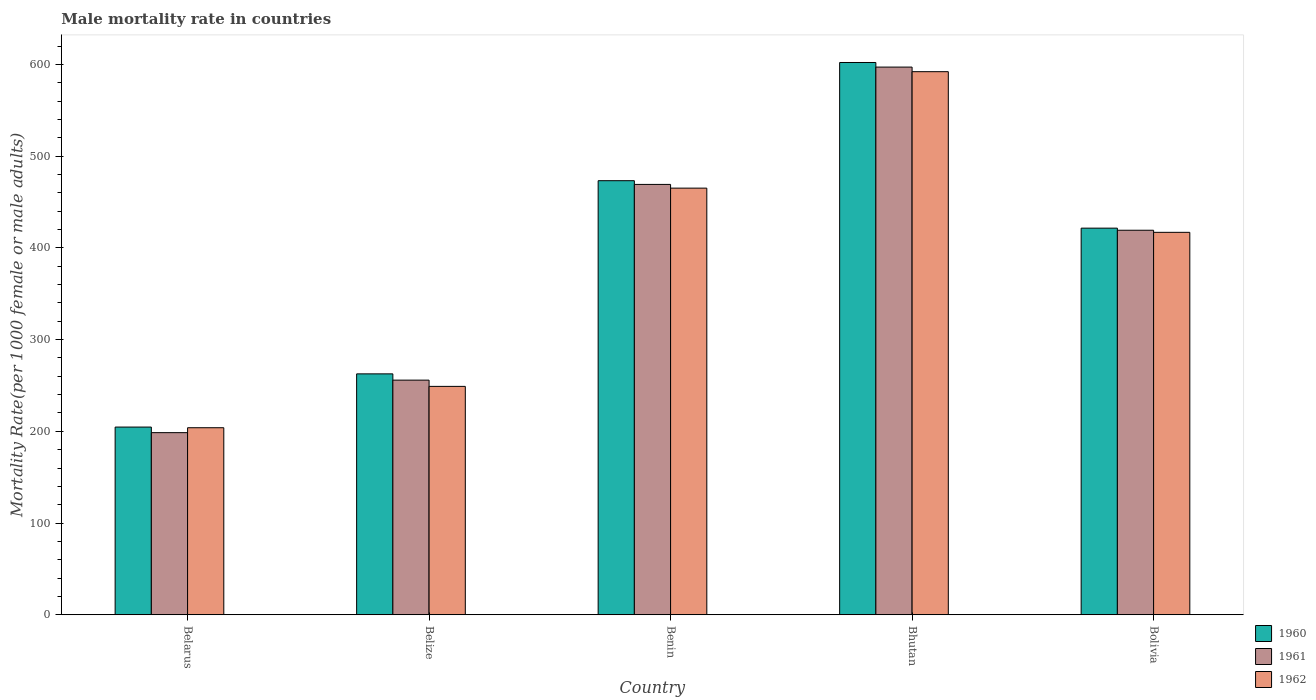Are the number of bars per tick equal to the number of legend labels?
Your response must be concise. Yes. What is the label of the 5th group of bars from the left?
Your answer should be very brief. Bolivia. What is the male mortality rate in 1962 in Bolivia?
Provide a succinct answer. 416.93. Across all countries, what is the maximum male mortality rate in 1960?
Offer a very short reply. 602.1. Across all countries, what is the minimum male mortality rate in 1962?
Offer a terse response. 203.93. In which country was the male mortality rate in 1960 maximum?
Keep it short and to the point. Bhutan. In which country was the male mortality rate in 1961 minimum?
Offer a terse response. Belarus. What is the total male mortality rate in 1960 in the graph?
Your answer should be compact. 1964.12. What is the difference between the male mortality rate in 1961 in Belize and that in Bhutan?
Your answer should be very brief. -341.27. What is the difference between the male mortality rate in 1960 in Belize and the male mortality rate in 1961 in Benin?
Keep it short and to the point. -206.54. What is the average male mortality rate in 1960 per country?
Your answer should be very brief. 392.82. What is the difference between the male mortality rate of/in 1961 and male mortality rate of/in 1960 in Belarus?
Your response must be concise. -6.1. In how many countries, is the male mortality rate in 1960 greater than 180?
Your answer should be compact. 5. What is the ratio of the male mortality rate in 1961 in Bhutan to that in Bolivia?
Your answer should be very brief. 1.42. What is the difference between the highest and the second highest male mortality rate in 1960?
Offer a terse response. -128.86. What is the difference between the highest and the lowest male mortality rate in 1960?
Make the answer very short. 397.45. Is the sum of the male mortality rate in 1962 in Belarus and Bolivia greater than the maximum male mortality rate in 1960 across all countries?
Give a very brief answer. Yes. What does the 1st bar from the left in Belize represents?
Offer a terse response. 1960. What does the 2nd bar from the right in Bolivia represents?
Provide a short and direct response. 1961. Is it the case that in every country, the sum of the male mortality rate in 1962 and male mortality rate in 1960 is greater than the male mortality rate in 1961?
Provide a succinct answer. Yes. How many bars are there?
Your response must be concise. 15. Are all the bars in the graph horizontal?
Your answer should be compact. No. How many countries are there in the graph?
Make the answer very short. 5. How many legend labels are there?
Keep it short and to the point. 3. What is the title of the graph?
Your response must be concise. Male mortality rate in countries. What is the label or title of the X-axis?
Keep it short and to the point. Country. What is the label or title of the Y-axis?
Give a very brief answer. Mortality Rate(per 1000 female or male adults). What is the Mortality Rate(per 1000 female or male adults) of 1960 in Belarus?
Offer a terse response. 204.65. What is the Mortality Rate(per 1000 female or male adults) in 1961 in Belarus?
Provide a short and direct response. 198.55. What is the Mortality Rate(per 1000 female or male adults) in 1962 in Belarus?
Your answer should be very brief. 203.93. What is the Mortality Rate(per 1000 female or male adults) in 1960 in Belize?
Your response must be concise. 262.64. What is the Mortality Rate(per 1000 female or male adults) in 1961 in Belize?
Provide a short and direct response. 255.81. What is the Mortality Rate(per 1000 female or male adults) of 1962 in Belize?
Your answer should be compact. 248.99. What is the Mortality Rate(per 1000 female or male adults) in 1960 in Benin?
Ensure brevity in your answer.  473.24. What is the Mortality Rate(per 1000 female or male adults) in 1961 in Benin?
Provide a succinct answer. 469.18. What is the Mortality Rate(per 1000 female or male adults) of 1962 in Benin?
Make the answer very short. 465.12. What is the Mortality Rate(per 1000 female or male adults) in 1960 in Bhutan?
Your response must be concise. 602.1. What is the Mortality Rate(per 1000 female or male adults) in 1961 in Bhutan?
Your answer should be compact. 597.09. What is the Mortality Rate(per 1000 female or male adults) of 1962 in Bhutan?
Offer a terse response. 592.08. What is the Mortality Rate(per 1000 female or male adults) of 1960 in Bolivia?
Make the answer very short. 421.5. What is the Mortality Rate(per 1000 female or male adults) of 1961 in Bolivia?
Ensure brevity in your answer.  419.21. What is the Mortality Rate(per 1000 female or male adults) in 1962 in Bolivia?
Keep it short and to the point. 416.93. Across all countries, what is the maximum Mortality Rate(per 1000 female or male adults) in 1960?
Provide a succinct answer. 602.1. Across all countries, what is the maximum Mortality Rate(per 1000 female or male adults) in 1961?
Offer a very short reply. 597.09. Across all countries, what is the maximum Mortality Rate(per 1000 female or male adults) of 1962?
Your answer should be compact. 592.08. Across all countries, what is the minimum Mortality Rate(per 1000 female or male adults) of 1960?
Provide a succinct answer. 204.65. Across all countries, what is the minimum Mortality Rate(per 1000 female or male adults) in 1961?
Provide a succinct answer. 198.55. Across all countries, what is the minimum Mortality Rate(per 1000 female or male adults) in 1962?
Ensure brevity in your answer.  203.93. What is the total Mortality Rate(per 1000 female or male adults) of 1960 in the graph?
Make the answer very short. 1964.12. What is the total Mortality Rate(per 1000 female or male adults) in 1961 in the graph?
Keep it short and to the point. 1939.85. What is the total Mortality Rate(per 1000 female or male adults) in 1962 in the graph?
Offer a very short reply. 1927.05. What is the difference between the Mortality Rate(per 1000 female or male adults) of 1960 in Belarus and that in Belize?
Offer a terse response. -57.99. What is the difference between the Mortality Rate(per 1000 female or male adults) in 1961 in Belarus and that in Belize?
Your answer should be very brief. -57.27. What is the difference between the Mortality Rate(per 1000 female or male adults) of 1962 in Belarus and that in Belize?
Provide a short and direct response. -45.06. What is the difference between the Mortality Rate(per 1000 female or male adults) in 1960 in Belarus and that in Benin?
Provide a short and direct response. -268.59. What is the difference between the Mortality Rate(per 1000 female or male adults) of 1961 in Belarus and that in Benin?
Provide a short and direct response. -270.63. What is the difference between the Mortality Rate(per 1000 female or male adults) of 1962 in Belarus and that in Benin?
Your answer should be compact. -261.19. What is the difference between the Mortality Rate(per 1000 female or male adults) in 1960 in Belarus and that in Bhutan?
Make the answer very short. -397.45. What is the difference between the Mortality Rate(per 1000 female or male adults) of 1961 in Belarus and that in Bhutan?
Offer a very short reply. -398.54. What is the difference between the Mortality Rate(per 1000 female or male adults) of 1962 in Belarus and that in Bhutan?
Offer a very short reply. -388.15. What is the difference between the Mortality Rate(per 1000 female or male adults) in 1960 in Belarus and that in Bolivia?
Provide a succinct answer. -216.86. What is the difference between the Mortality Rate(per 1000 female or male adults) in 1961 in Belarus and that in Bolivia?
Offer a terse response. -220.66. What is the difference between the Mortality Rate(per 1000 female or male adults) of 1962 in Belarus and that in Bolivia?
Offer a terse response. -213. What is the difference between the Mortality Rate(per 1000 female or male adults) in 1960 in Belize and that in Benin?
Ensure brevity in your answer.  -210.6. What is the difference between the Mortality Rate(per 1000 female or male adults) of 1961 in Belize and that in Benin?
Ensure brevity in your answer.  -213.37. What is the difference between the Mortality Rate(per 1000 female or male adults) of 1962 in Belize and that in Benin?
Your response must be concise. -216.13. What is the difference between the Mortality Rate(per 1000 female or male adults) in 1960 in Belize and that in Bhutan?
Your answer should be compact. -339.46. What is the difference between the Mortality Rate(per 1000 female or male adults) of 1961 in Belize and that in Bhutan?
Offer a very short reply. -341.27. What is the difference between the Mortality Rate(per 1000 female or male adults) in 1962 in Belize and that in Bhutan?
Offer a very short reply. -343.09. What is the difference between the Mortality Rate(per 1000 female or male adults) in 1960 in Belize and that in Bolivia?
Offer a very short reply. -158.87. What is the difference between the Mortality Rate(per 1000 female or male adults) of 1961 in Belize and that in Bolivia?
Provide a short and direct response. -163.4. What is the difference between the Mortality Rate(per 1000 female or male adults) of 1962 in Belize and that in Bolivia?
Your response must be concise. -167.93. What is the difference between the Mortality Rate(per 1000 female or male adults) of 1960 in Benin and that in Bhutan?
Your answer should be compact. -128.86. What is the difference between the Mortality Rate(per 1000 female or male adults) in 1961 in Benin and that in Bhutan?
Keep it short and to the point. -127.91. What is the difference between the Mortality Rate(per 1000 female or male adults) in 1962 in Benin and that in Bhutan?
Make the answer very short. -126.96. What is the difference between the Mortality Rate(per 1000 female or male adults) of 1960 in Benin and that in Bolivia?
Provide a succinct answer. 51.73. What is the difference between the Mortality Rate(per 1000 female or male adults) of 1961 in Benin and that in Bolivia?
Ensure brevity in your answer.  49.97. What is the difference between the Mortality Rate(per 1000 female or male adults) of 1962 in Benin and that in Bolivia?
Your answer should be very brief. 48.2. What is the difference between the Mortality Rate(per 1000 female or male adults) of 1960 in Bhutan and that in Bolivia?
Provide a succinct answer. 180.59. What is the difference between the Mortality Rate(per 1000 female or male adults) in 1961 in Bhutan and that in Bolivia?
Make the answer very short. 177.87. What is the difference between the Mortality Rate(per 1000 female or male adults) of 1962 in Bhutan and that in Bolivia?
Provide a short and direct response. 175.15. What is the difference between the Mortality Rate(per 1000 female or male adults) of 1960 in Belarus and the Mortality Rate(per 1000 female or male adults) of 1961 in Belize?
Your answer should be compact. -51.17. What is the difference between the Mortality Rate(per 1000 female or male adults) in 1960 in Belarus and the Mortality Rate(per 1000 female or male adults) in 1962 in Belize?
Make the answer very short. -44.35. What is the difference between the Mortality Rate(per 1000 female or male adults) in 1961 in Belarus and the Mortality Rate(per 1000 female or male adults) in 1962 in Belize?
Give a very brief answer. -50.44. What is the difference between the Mortality Rate(per 1000 female or male adults) in 1960 in Belarus and the Mortality Rate(per 1000 female or male adults) in 1961 in Benin?
Provide a succinct answer. -264.53. What is the difference between the Mortality Rate(per 1000 female or male adults) in 1960 in Belarus and the Mortality Rate(per 1000 female or male adults) in 1962 in Benin?
Keep it short and to the point. -260.48. What is the difference between the Mortality Rate(per 1000 female or male adults) in 1961 in Belarus and the Mortality Rate(per 1000 female or male adults) in 1962 in Benin?
Your response must be concise. -266.57. What is the difference between the Mortality Rate(per 1000 female or male adults) of 1960 in Belarus and the Mortality Rate(per 1000 female or male adults) of 1961 in Bhutan?
Your answer should be compact. -392.44. What is the difference between the Mortality Rate(per 1000 female or male adults) in 1960 in Belarus and the Mortality Rate(per 1000 female or male adults) in 1962 in Bhutan?
Keep it short and to the point. -387.43. What is the difference between the Mortality Rate(per 1000 female or male adults) in 1961 in Belarus and the Mortality Rate(per 1000 female or male adults) in 1962 in Bhutan?
Your response must be concise. -393.53. What is the difference between the Mortality Rate(per 1000 female or male adults) of 1960 in Belarus and the Mortality Rate(per 1000 female or male adults) of 1961 in Bolivia?
Keep it short and to the point. -214.57. What is the difference between the Mortality Rate(per 1000 female or male adults) of 1960 in Belarus and the Mortality Rate(per 1000 female or male adults) of 1962 in Bolivia?
Keep it short and to the point. -212.28. What is the difference between the Mortality Rate(per 1000 female or male adults) of 1961 in Belarus and the Mortality Rate(per 1000 female or male adults) of 1962 in Bolivia?
Offer a terse response. -218.38. What is the difference between the Mortality Rate(per 1000 female or male adults) of 1960 in Belize and the Mortality Rate(per 1000 female or male adults) of 1961 in Benin?
Offer a terse response. -206.54. What is the difference between the Mortality Rate(per 1000 female or male adults) of 1960 in Belize and the Mortality Rate(per 1000 female or male adults) of 1962 in Benin?
Your response must be concise. -202.49. What is the difference between the Mortality Rate(per 1000 female or male adults) in 1961 in Belize and the Mortality Rate(per 1000 female or male adults) in 1962 in Benin?
Provide a short and direct response. -209.31. What is the difference between the Mortality Rate(per 1000 female or male adults) in 1960 in Belize and the Mortality Rate(per 1000 female or male adults) in 1961 in Bhutan?
Offer a very short reply. -334.45. What is the difference between the Mortality Rate(per 1000 female or male adults) in 1960 in Belize and the Mortality Rate(per 1000 female or male adults) in 1962 in Bhutan?
Offer a very short reply. -329.44. What is the difference between the Mortality Rate(per 1000 female or male adults) in 1961 in Belize and the Mortality Rate(per 1000 female or male adults) in 1962 in Bhutan?
Ensure brevity in your answer.  -336.26. What is the difference between the Mortality Rate(per 1000 female or male adults) in 1960 in Belize and the Mortality Rate(per 1000 female or male adults) in 1961 in Bolivia?
Ensure brevity in your answer.  -156.58. What is the difference between the Mortality Rate(per 1000 female or male adults) of 1960 in Belize and the Mortality Rate(per 1000 female or male adults) of 1962 in Bolivia?
Keep it short and to the point. -154.29. What is the difference between the Mortality Rate(per 1000 female or male adults) of 1961 in Belize and the Mortality Rate(per 1000 female or male adults) of 1962 in Bolivia?
Provide a succinct answer. -161.11. What is the difference between the Mortality Rate(per 1000 female or male adults) in 1960 in Benin and the Mortality Rate(per 1000 female or male adults) in 1961 in Bhutan?
Ensure brevity in your answer.  -123.85. What is the difference between the Mortality Rate(per 1000 female or male adults) in 1960 in Benin and the Mortality Rate(per 1000 female or male adults) in 1962 in Bhutan?
Make the answer very short. -118.84. What is the difference between the Mortality Rate(per 1000 female or male adults) of 1961 in Benin and the Mortality Rate(per 1000 female or male adults) of 1962 in Bhutan?
Offer a terse response. -122.9. What is the difference between the Mortality Rate(per 1000 female or male adults) of 1960 in Benin and the Mortality Rate(per 1000 female or male adults) of 1961 in Bolivia?
Your answer should be compact. 54.02. What is the difference between the Mortality Rate(per 1000 female or male adults) of 1960 in Benin and the Mortality Rate(per 1000 female or male adults) of 1962 in Bolivia?
Provide a succinct answer. 56.31. What is the difference between the Mortality Rate(per 1000 female or male adults) in 1961 in Benin and the Mortality Rate(per 1000 female or male adults) in 1962 in Bolivia?
Offer a very short reply. 52.25. What is the difference between the Mortality Rate(per 1000 female or male adults) of 1960 in Bhutan and the Mortality Rate(per 1000 female or male adults) of 1961 in Bolivia?
Provide a short and direct response. 182.88. What is the difference between the Mortality Rate(per 1000 female or male adults) in 1960 in Bhutan and the Mortality Rate(per 1000 female or male adults) in 1962 in Bolivia?
Your answer should be compact. 185.17. What is the difference between the Mortality Rate(per 1000 female or male adults) of 1961 in Bhutan and the Mortality Rate(per 1000 female or male adults) of 1962 in Bolivia?
Your response must be concise. 180.16. What is the average Mortality Rate(per 1000 female or male adults) of 1960 per country?
Provide a short and direct response. 392.82. What is the average Mortality Rate(per 1000 female or male adults) of 1961 per country?
Your answer should be very brief. 387.97. What is the average Mortality Rate(per 1000 female or male adults) of 1962 per country?
Make the answer very short. 385.41. What is the difference between the Mortality Rate(per 1000 female or male adults) in 1960 and Mortality Rate(per 1000 female or male adults) in 1961 in Belarus?
Your answer should be compact. 6.1. What is the difference between the Mortality Rate(per 1000 female or male adults) of 1960 and Mortality Rate(per 1000 female or male adults) of 1962 in Belarus?
Give a very brief answer. 0.72. What is the difference between the Mortality Rate(per 1000 female or male adults) in 1961 and Mortality Rate(per 1000 female or male adults) in 1962 in Belarus?
Your response must be concise. -5.38. What is the difference between the Mortality Rate(per 1000 female or male adults) in 1960 and Mortality Rate(per 1000 female or male adults) in 1961 in Belize?
Your answer should be compact. 6.82. What is the difference between the Mortality Rate(per 1000 female or male adults) in 1960 and Mortality Rate(per 1000 female or male adults) in 1962 in Belize?
Ensure brevity in your answer.  13.64. What is the difference between the Mortality Rate(per 1000 female or male adults) in 1961 and Mortality Rate(per 1000 female or male adults) in 1962 in Belize?
Your response must be concise. 6.82. What is the difference between the Mortality Rate(per 1000 female or male adults) of 1960 and Mortality Rate(per 1000 female or male adults) of 1961 in Benin?
Keep it short and to the point. 4.06. What is the difference between the Mortality Rate(per 1000 female or male adults) of 1960 and Mortality Rate(per 1000 female or male adults) of 1962 in Benin?
Keep it short and to the point. 8.11. What is the difference between the Mortality Rate(per 1000 female or male adults) in 1961 and Mortality Rate(per 1000 female or male adults) in 1962 in Benin?
Provide a succinct answer. 4.06. What is the difference between the Mortality Rate(per 1000 female or male adults) in 1960 and Mortality Rate(per 1000 female or male adults) in 1961 in Bhutan?
Offer a very short reply. 5.01. What is the difference between the Mortality Rate(per 1000 female or male adults) in 1960 and Mortality Rate(per 1000 female or male adults) in 1962 in Bhutan?
Provide a succinct answer. 10.02. What is the difference between the Mortality Rate(per 1000 female or male adults) in 1961 and Mortality Rate(per 1000 female or male adults) in 1962 in Bhutan?
Offer a very short reply. 5.01. What is the difference between the Mortality Rate(per 1000 female or male adults) in 1960 and Mortality Rate(per 1000 female or male adults) in 1961 in Bolivia?
Your response must be concise. 2.29. What is the difference between the Mortality Rate(per 1000 female or male adults) of 1960 and Mortality Rate(per 1000 female or male adults) of 1962 in Bolivia?
Provide a succinct answer. 4.58. What is the difference between the Mortality Rate(per 1000 female or male adults) of 1961 and Mortality Rate(per 1000 female or male adults) of 1962 in Bolivia?
Give a very brief answer. 2.29. What is the ratio of the Mortality Rate(per 1000 female or male adults) of 1960 in Belarus to that in Belize?
Provide a short and direct response. 0.78. What is the ratio of the Mortality Rate(per 1000 female or male adults) in 1961 in Belarus to that in Belize?
Keep it short and to the point. 0.78. What is the ratio of the Mortality Rate(per 1000 female or male adults) of 1962 in Belarus to that in Belize?
Your response must be concise. 0.82. What is the ratio of the Mortality Rate(per 1000 female or male adults) of 1960 in Belarus to that in Benin?
Make the answer very short. 0.43. What is the ratio of the Mortality Rate(per 1000 female or male adults) in 1961 in Belarus to that in Benin?
Keep it short and to the point. 0.42. What is the ratio of the Mortality Rate(per 1000 female or male adults) in 1962 in Belarus to that in Benin?
Ensure brevity in your answer.  0.44. What is the ratio of the Mortality Rate(per 1000 female or male adults) in 1960 in Belarus to that in Bhutan?
Give a very brief answer. 0.34. What is the ratio of the Mortality Rate(per 1000 female or male adults) in 1961 in Belarus to that in Bhutan?
Make the answer very short. 0.33. What is the ratio of the Mortality Rate(per 1000 female or male adults) of 1962 in Belarus to that in Bhutan?
Provide a short and direct response. 0.34. What is the ratio of the Mortality Rate(per 1000 female or male adults) of 1960 in Belarus to that in Bolivia?
Provide a succinct answer. 0.49. What is the ratio of the Mortality Rate(per 1000 female or male adults) in 1961 in Belarus to that in Bolivia?
Provide a short and direct response. 0.47. What is the ratio of the Mortality Rate(per 1000 female or male adults) of 1962 in Belarus to that in Bolivia?
Offer a terse response. 0.49. What is the ratio of the Mortality Rate(per 1000 female or male adults) in 1960 in Belize to that in Benin?
Ensure brevity in your answer.  0.56. What is the ratio of the Mortality Rate(per 1000 female or male adults) in 1961 in Belize to that in Benin?
Keep it short and to the point. 0.55. What is the ratio of the Mortality Rate(per 1000 female or male adults) in 1962 in Belize to that in Benin?
Your answer should be compact. 0.54. What is the ratio of the Mortality Rate(per 1000 female or male adults) in 1960 in Belize to that in Bhutan?
Offer a very short reply. 0.44. What is the ratio of the Mortality Rate(per 1000 female or male adults) in 1961 in Belize to that in Bhutan?
Make the answer very short. 0.43. What is the ratio of the Mortality Rate(per 1000 female or male adults) in 1962 in Belize to that in Bhutan?
Your answer should be very brief. 0.42. What is the ratio of the Mortality Rate(per 1000 female or male adults) in 1960 in Belize to that in Bolivia?
Give a very brief answer. 0.62. What is the ratio of the Mortality Rate(per 1000 female or male adults) of 1961 in Belize to that in Bolivia?
Ensure brevity in your answer.  0.61. What is the ratio of the Mortality Rate(per 1000 female or male adults) in 1962 in Belize to that in Bolivia?
Provide a succinct answer. 0.6. What is the ratio of the Mortality Rate(per 1000 female or male adults) of 1960 in Benin to that in Bhutan?
Make the answer very short. 0.79. What is the ratio of the Mortality Rate(per 1000 female or male adults) of 1961 in Benin to that in Bhutan?
Make the answer very short. 0.79. What is the ratio of the Mortality Rate(per 1000 female or male adults) in 1962 in Benin to that in Bhutan?
Give a very brief answer. 0.79. What is the ratio of the Mortality Rate(per 1000 female or male adults) in 1960 in Benin to that in Bolivia?
Your response must be concise. 1.12. What is the ratio of the Mortality Rate(per 1000 female or male adults) of 1961 in Benin to that in Bolivia?
Ensure brevity in your answer.  1.12. What is the ratio of the Mortality Rate(per 1000 female or male adults) in 1962 in Benin to that in Bolivia?
Provide a short and direct response. 1.12. What is the ratio of the Mortality Rate(per 1000 female or male adults) in 1960 in Bhutan to that in Bolivia?
Offer a terse response. 1.43. What is the ratio of the Mortality Rate(per 1000 female or male adults) of 1961 in Bhutan to that in Bolivia?
Offer a very short reply. 1.42. What is the ratio of the Mortality Rate(per 1000 female or male adults) of 1962 in Bhutan to that in Bolivia?
Keep it short and to the point. 1.42. What is the difference between the highest and the second highest Mortality Rate(per 1000 female or male adults) of 1960?
Give a very brief answer. 128.86. What is the difference between the highest and the second highest Mortality Rate(per 1000 female or male adults) of 1961?
Make the answer very short. 127.91. What is the difference between the highest and the second highest Mortality Rate(per 1000 female or male adults) of 1962?
Your answer should be compact. 126.96. What is the difference between the highest and the lowest Mortality Rate(per 1000 female or male adults) of 1960?
Provide a succinct answer. 397.45. What is the difference between the highest and the lowest Mortality Rate(per 1000 female or male adults) of 1961?
Keep it short and to the point. 398.54. What is the difference between the highest and the lowest Mortality Rate(per 1000 female or male adults) in 1962?
Your response must be concise. 388.15. 